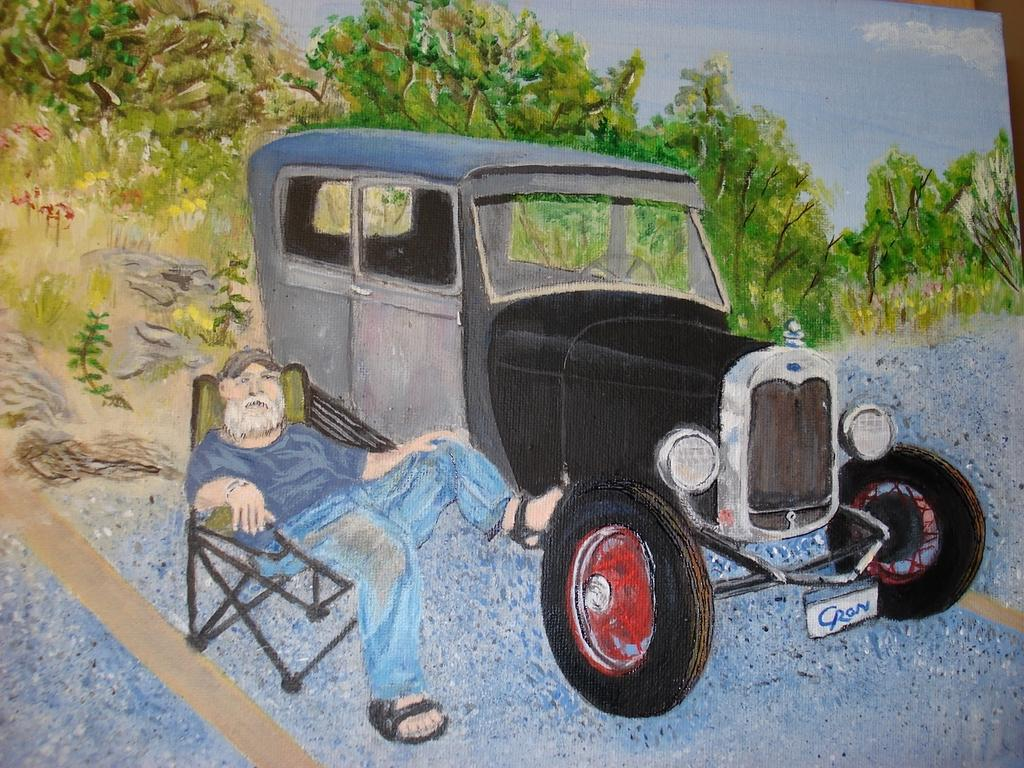What is depicted in the painting in the image? There is a painting of a car in the image. Are there any people in the painting? Yes, there is a man sitting on a chair in the painting. What other elements can be seen in the painting? There is a painting of trees in the image. How much money is being exchanged between the man and the trees in the painting? There is no exchange of money depicted in the painting; it features a man sitting on a chair and trees. 